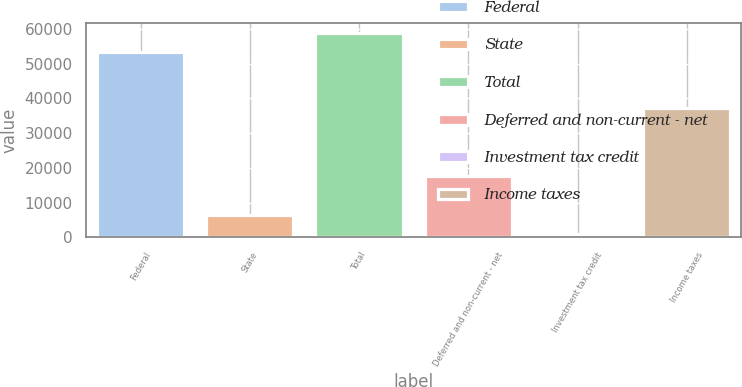Convert chart to OTSL. <chart><loc_0><loc_0><loc_500><loc_500><bar_chart><fcel>Federal<fcel>State<fcel>Total<fcel>Deferred and non-current - net<fcel>Investment tax credit<fcel>Income taxes<nl><fcel>53313<fcel>6398.9<fcel>58797.9<fcel>17599<fcel>914<fcel>37250<nl></chart> 